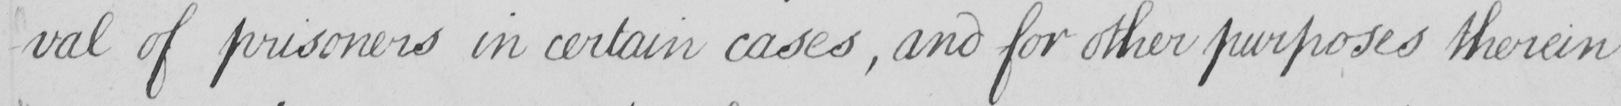Transcribe the text shown in this historical manuscript line. -val of prisoners in certain cases  , and for other purposes therein 